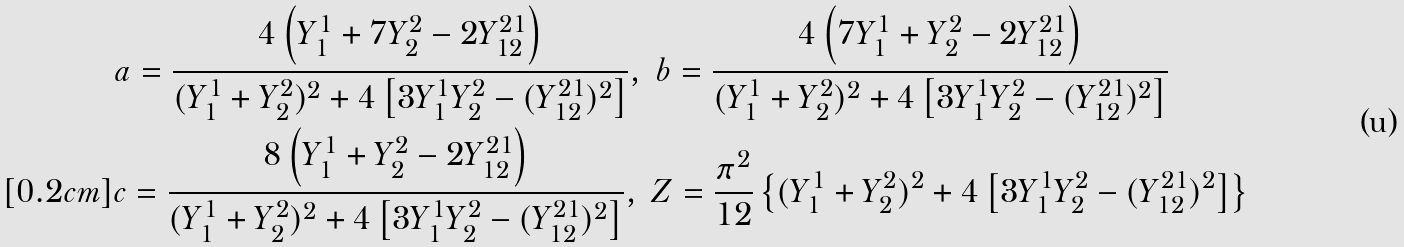Convert formula to latex. <formula><loc_0><loc_0><loc_500><loc_500>& a = \frac { 4 \left ( Y _ { 1 } ^ { 1 } + 7 Y _ { 2 } ^ { 2 } - 2 Y _ { 1 2 } ^ { 2 1 } \right ) } { ( Y _ { 1 } ^ { 1 } + Y _ { 2 } ^ { 2 } ) ^ { 2 } + 4 \left [ 3 Y _ { 1 } ^ { 1 } Y _ { 2 } ^ { 2 } - ( Y _ { 1 2 } ^ { 2 1 } ) ^ { 2 } \right ] } , \ b = \frac { 4 \left ( 7 Y _ { 1 } ^ { 1 } + Y _ { 2 } ^ { 2 } - 2 Y _ { 1 2 } ^ { 2 1 } \right ) } { ( Y _ { 1 } ^ { 1 } + Y _ { 2 } ^ { 2 } ) ^ { 2 } + 4 \left [ 3 Y _ { 1 } ^ { 1 } Y _ { 2 } ^ { 2 } - ( Y _ { 1 2 } ^ { 2 1 } ) ^ { 2 } \right ] } \\ [ 0 . 2 c m ] & c = \frac { 8 \left ( Y _ { 1 } ^ { 1 } + Y _ { 2 } ^ { 2 } - 2 Y _ { 1 2 } ^ { 2 1 } \right ) } { ( Y _ { 1 } ^ { 1 } + Y _ { 2 } ^ { 2 } ) ^ { 2 } + 4 \left [ 3 Y _ { 1 } ^ { 1 } Y _ { 2 } ^ { 2 } - ( Y _ { 1 2 } ^ { 2 1 } ) ^ { 2 } \right ] } , \ Z = \frac { \pi ^ { 2 } } { 1 2 } \left \{ ( Y _ { 1 } ^ { 1 } + Y _ { 2 } ^ { 2 } ) ^ { 2 } + 4 \left [ 3 Y _ { 1 } ^ { 1 } Y _ { 2 } ^ { 2 } - ( Y _ { 1 2 } ^ { 2 1 } ) ^ { 2 } \right ] \right \}</formula> 